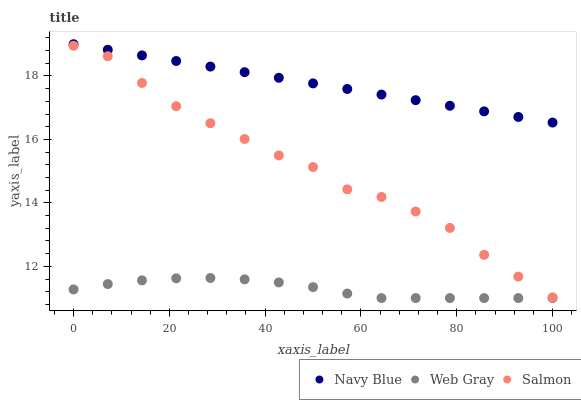Does Web Gray have the minimum area under the curve?
Answer yes or no. Yes. Does Navy Blue have the maximum area under the curve?
Answer yes or no. Yes. Does Salmon have the minimum area under the curve?
Answer yes or no. No. Does Salmon have the maximum area under the curve?
Answer yes or no. No. Is Navy Blue the smoothest?
Answer yes or no. Yes. Is Salmon the roughest?
Answer yes or no. Yes. Is Web Gray the smoothest?
Answer yes or no. No. Is Web Gray the roughest?
Answer yes or no. No. Does Web Gray have the lowest value?
Answer yes or no. Yes. Does Salmon have the lowest value?
Answer yes or no. No. Does Navy Blue have the highest value?
Answer yes or no. Yes. Does Salmon have the highest value?
Answer yes or no. No. Is Web Gray less than Navy Blue?
Answer yes or no. Yes. Is Navy Blue greater than Web Gray?
Answer yes or no. Yes. Does Web Gray intersect Navy Blue?
Answer yes or no. No. 